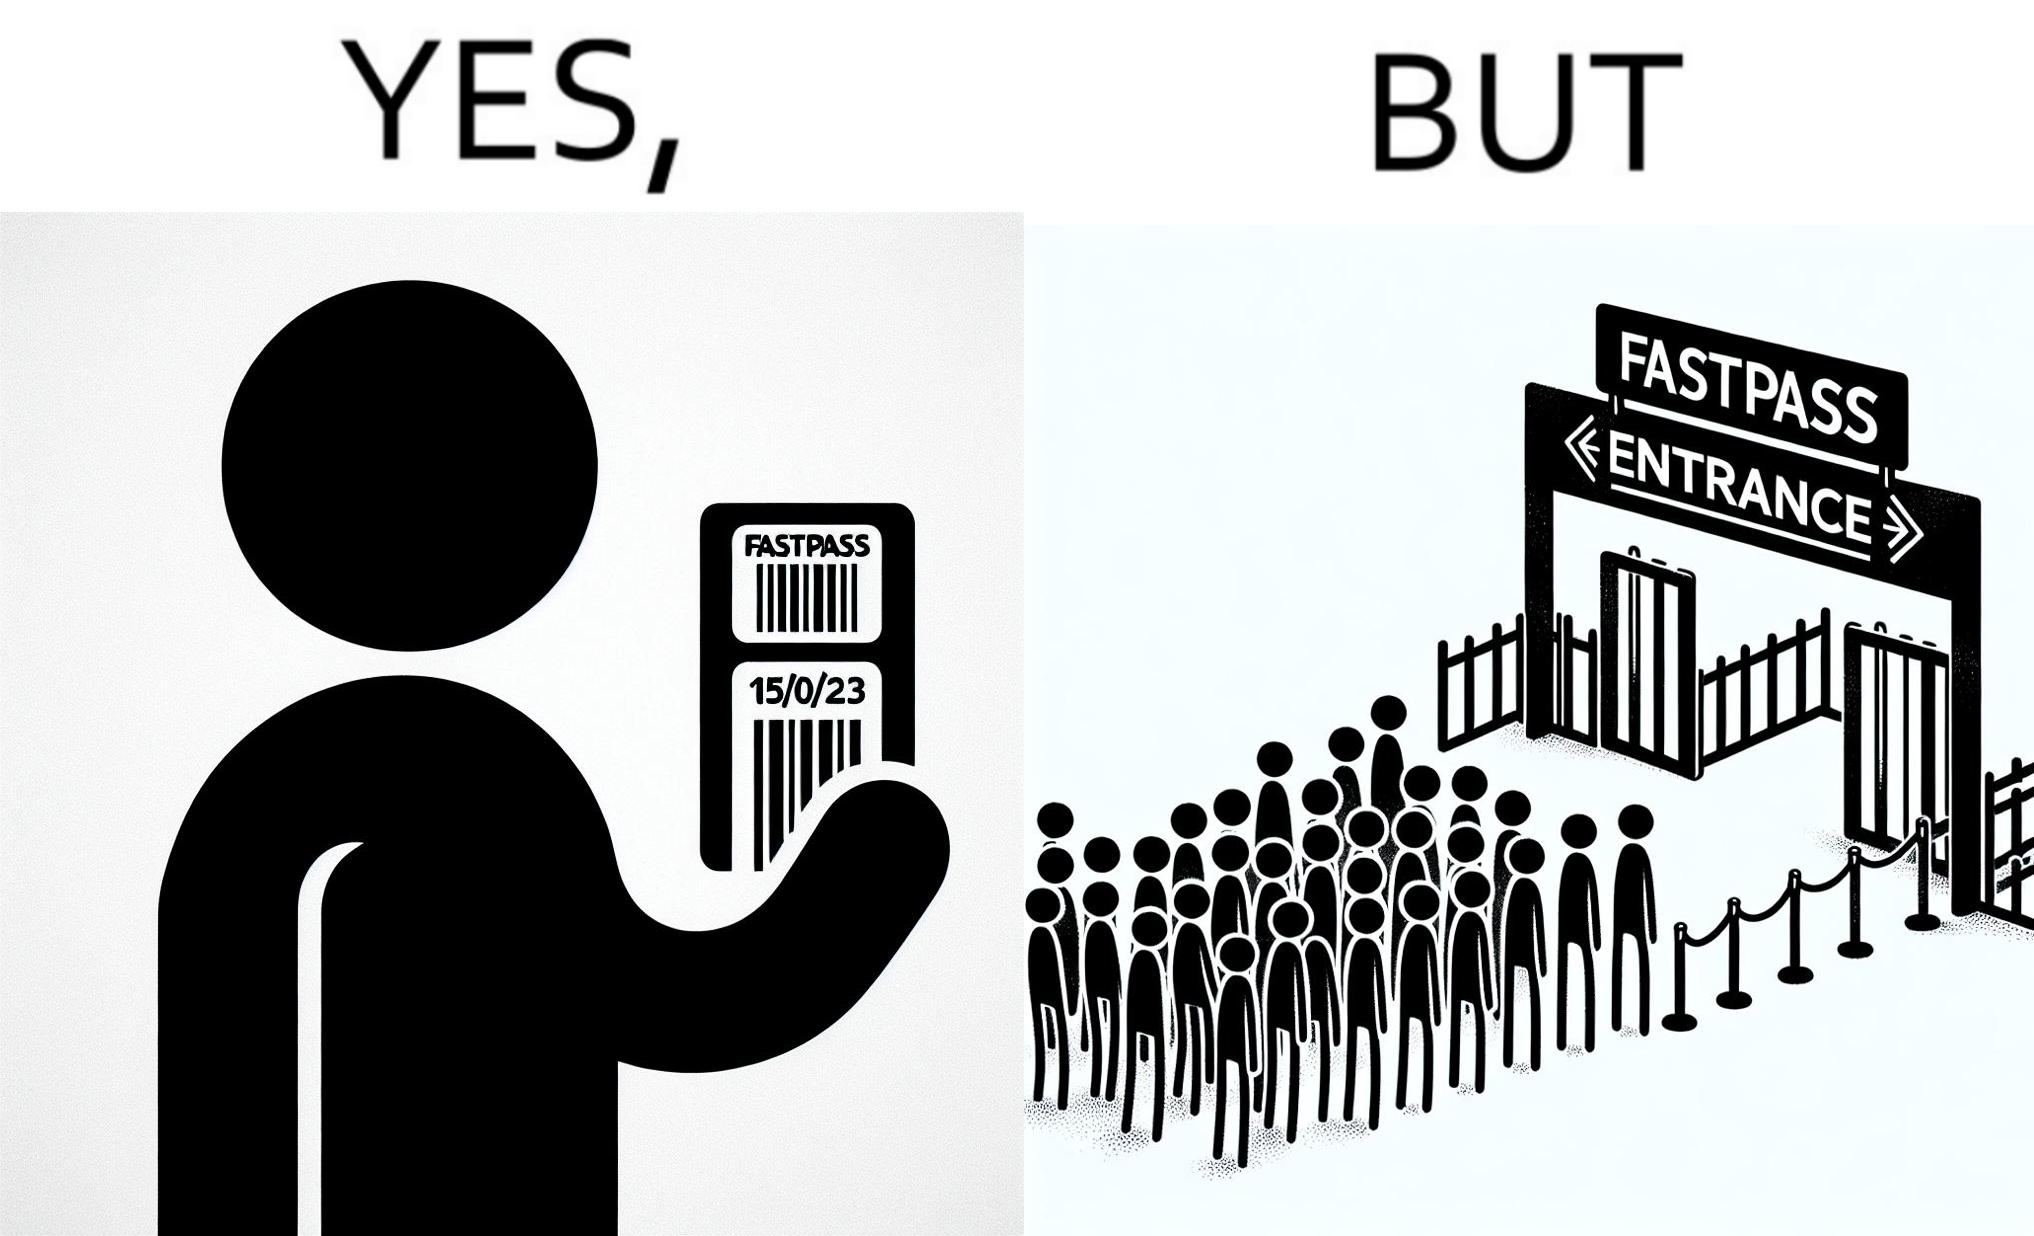Provide a description of this image. The image is ironic, because fast pass entrance was meant for people to pass the gate fast but as more no. of people bought the pass due to which the queue has become longer and it becomes slow and time consuming 